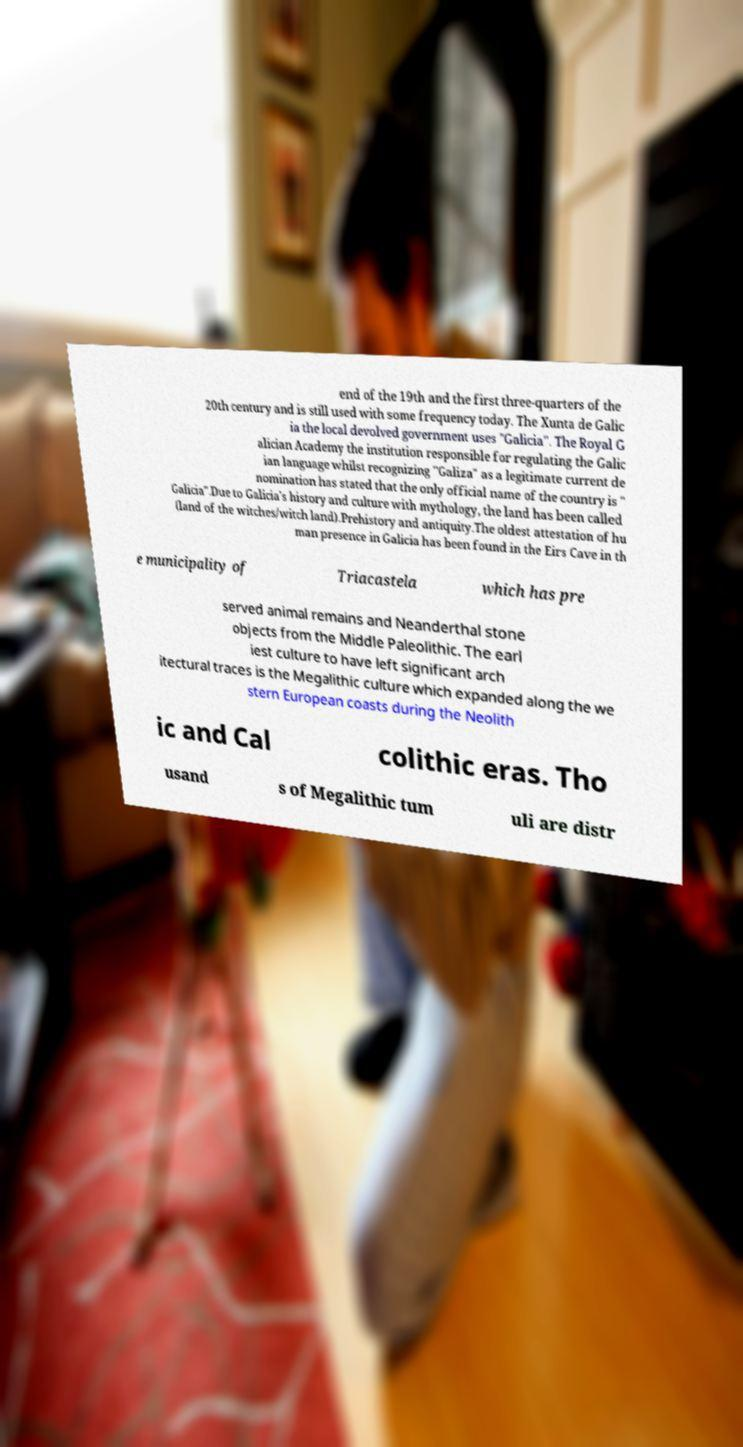I need the written content from this picture converted into text. Can you do that? end of the 19th and the first three-quarters of the 20th century and is still used with some frequency today. The Xunta de Galic ia the local devolved government uses "Galicia". The Royal G alician Academy the institution responsible for regulating the Galic ian language whilst recognizing "Galiza" as a legitimate current de nomination has stated that the only official name of the country is " Galicia".Due to Galicia's history and culture with mythology, the land has been called (land of the witches/witch land).Prehistory and antiquity.The oldest attestation of hu man presence in Galicia has been found in the Eirs Cave in th e municipality of Triacastela which has pre served animal remains and Neanderthal stone objects from the Middle Paleolithic. The earl iest culture to have left significant arch itectural traces is the Megalithic culture which expanded along the we stern European coasts during the Neolith ic and Cal colithic eras. Tho usand s of Megalithic tum uli are distr 